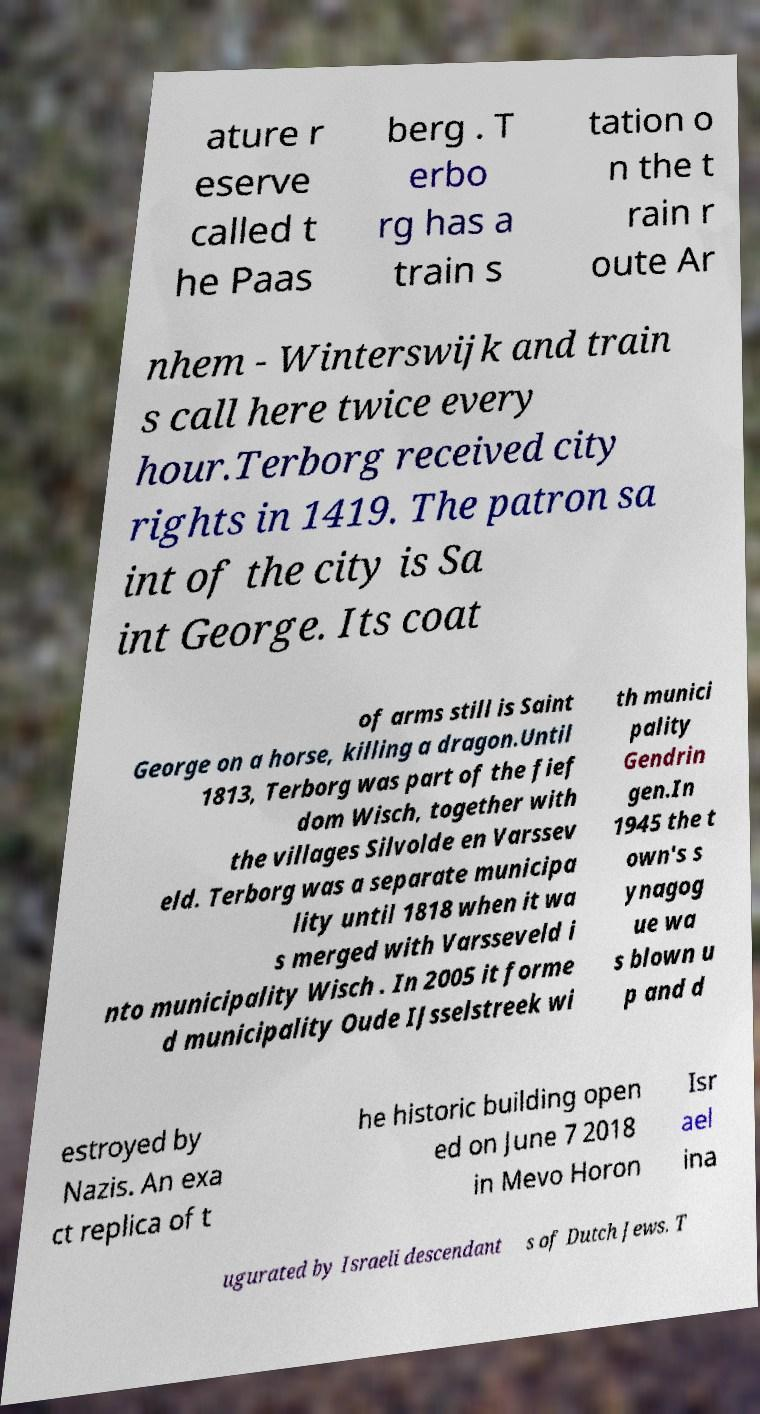Please identify and transcribe the text found in this image. ature r eserve called t he Paas berg . T erbo rg has a train s tation o n the t rain r oute Ar nhem - Winterswijk and train s call here twice every hour.Terborg received city rights in 1419. The patron sa int of the city is Sa int George. Its coat of arms still is Saint George on a horse, killing a dragon.Until 1813, Terborg was part of the fief dom Wisch, together with the villages Silvolde en Varssev eld. Terborg was a separate municipa lity until 1818 when it wa s merged with Varsseveld i nto municipality Wisch . In 2005 it forme d municipality Oude IJsselstreek wi th munici pality Gendrin gen.In 1945 the t own's s ynagog ue wa s blown u p and d estroyed by Nazis. An exa ct replica of t he historic building open ed on June 7 2018 in Mevo Horon Isr ael ina ugurated by Israeli descendant s of Dutch Jews. T 